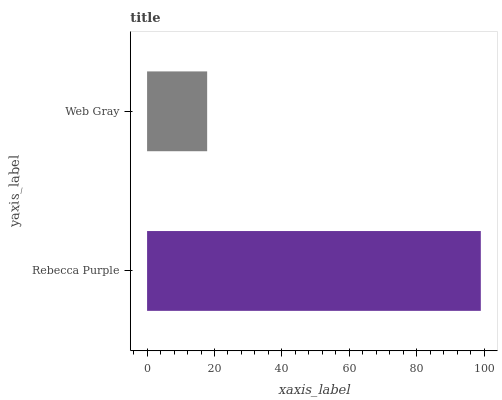Is Web Gray the minimum?
Answer yes or no. Yes. Is Rebecca Purple the maximum?
Answer yes or no. Yes. Is Web Gray the maximum?
Answer yes or no. No. Is Rebecca Purple greater than Web Gray?
Answer yes or no. Yes. Is Web Gray less than Rebecca Purple?
Answer yes or no. Yes. Is Web Gray greater than Rebecca Purple?
Answer yes or no. No. Is Rebecca Purple less than Web Gray?
Answer yes or no. No. Is Rebecca Purple the high median?
Answer yes or no. Yes. Is Web Gray the low median?
Answer yes or no. Yes. Is Web Gray the high median?
Answer yes or no. No. Is Rebecca Purple the low median?
Answer yes or no. No. 